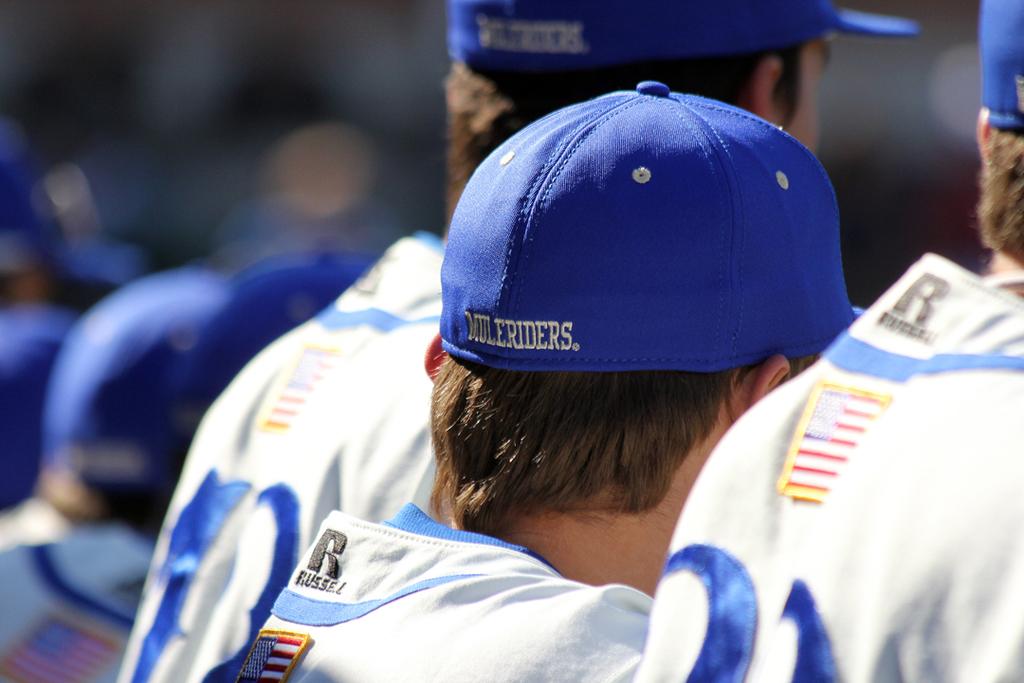What is the team name on their hats?
Make the answer very short. Muleriders. What brand made the jerseys?
Keep it short and to the point. Russell. 